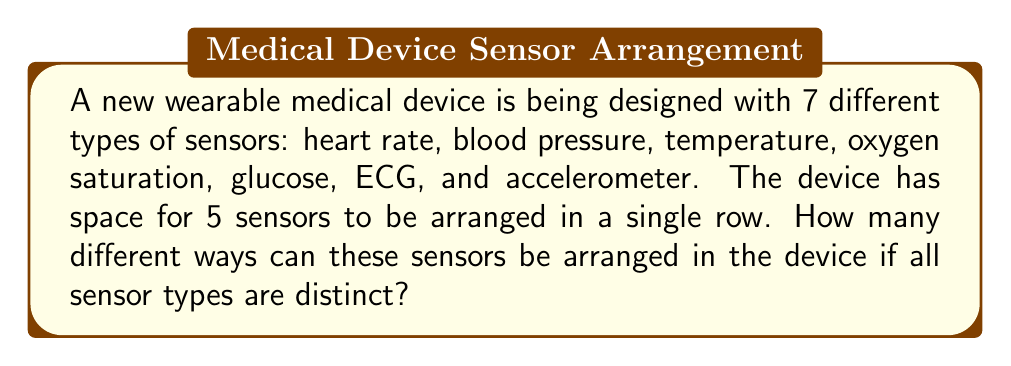Can you solve this math problem? To solve this problem, we need to use the concept of permutations. Here's a step-by-step explanation:

1. We have 7 different types of sensors (n = 7) and we need to choose and arrange 5 of them (r = 5).

2. This is a permutation problem because the order matters (different arrangements of the same sensors are considered distinct).

3. We are selecting 5 sensors out of 7, and the order is important. This scenario is known as a permutation without repetition.

4. The formula for permutations without repetition is:

   $$P(n,r) = \frac{n!}{(n-r)!}$$

   Where n is the total number of items to choose from, and r is the number of items being chosen.

5. Substituting our values:

   $$P(7,5) = \frac{7!}{(7-5)!} = \frac{7!}{2!}$$

6. Expanding this:

   $$\frac{7 \times 6 \times 5 \times 4 \times 3 \times 2!}{2!}$$

7. The 2! cancels out:

   $$7 \times 6 \times 5 \times 4 \times 3 = 2520$$

Therefore, there are 2520 different ways to arrange 5 sensors chosen from 7 types in the wearable device.
Answer: 2520 different arrangements 